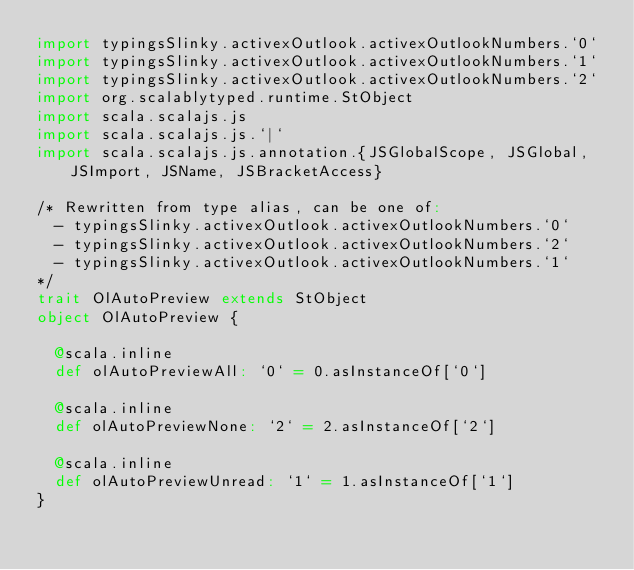Convert code to text. <code><loc_0><loc_0><loc_500><loc_500><_Scala_>import typingsSlinky.activexOutlook.activexOutlookNumbers.`0`
import typingsSlinky.activexOutlook.activexOutlookNumbers.`1`
import typingsSlinky.activexOutlook.activexOutlookNumbers.`2`
import org.scalablytyped.runtime.StObject
import scala.scalajs.js
import scala.scalajs.js.`|`
import scala.scalajs.js.annotation.{JSGlobalScope, JSGlobal, JSImport, JSName, JSBracketAccess}

/* Rewritten from type alias, can be one of: 
  - typingsSlinky.activexOutlook.activexOutlookNumbers.`0`
  - typingsSlinky.activexOutlook.activexOutlookNumbers.`2`
  - typingsSlinky.activexOutlook.activexOutlookNumbers.`1`
*/
trait OlAutoPreview extends StObject
object OlAutoPreview {
  
  @scala.inline
  def olAutoPreviewAll: `0` = 0.asInstanceOf[`0`]
  
  @scala.inline
  def olAutoPreviewNone: `2` = 2.asInstanceOf[`2`]
  
  @scala.inline
  def olAutoPreviewUnread: `1` = 1.asInstanceOf[`1`]
}
</code> 